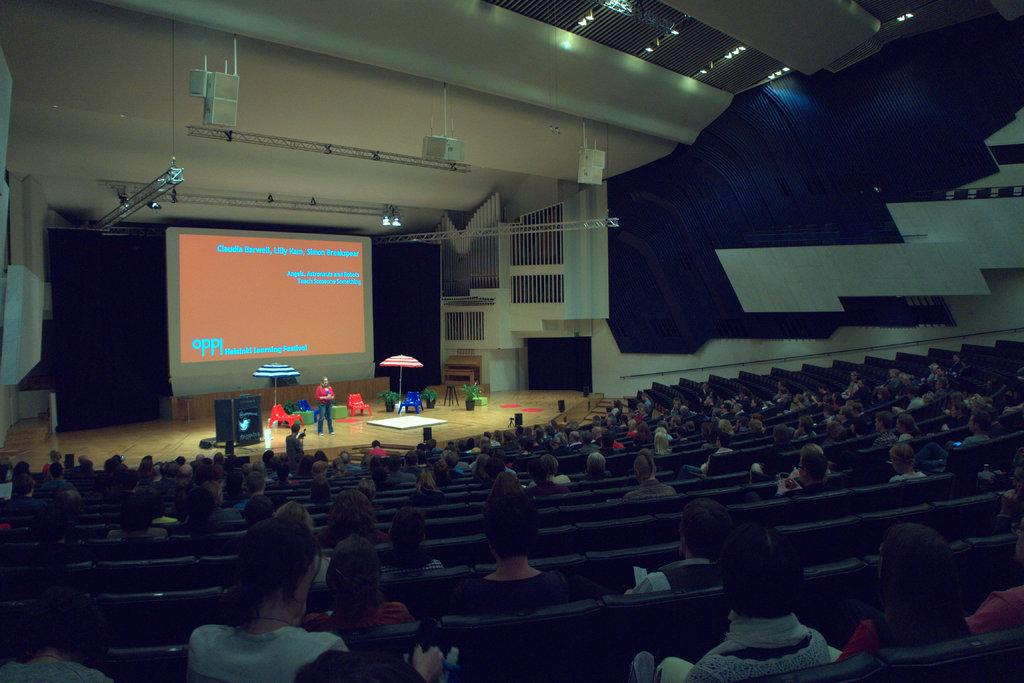<image>
Offer a succinct explanation of the picture presented. Claudia Barwell is part of the group doing the presentation at this lecture theatre. 